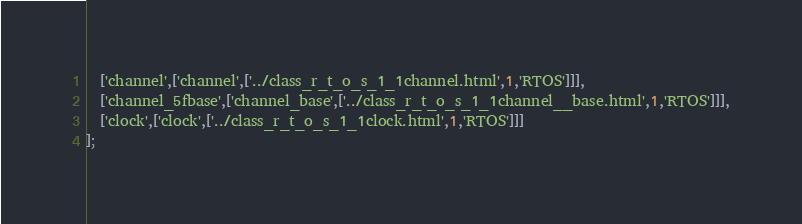<code> <loc_0><loc_0><loc_500><loc_500><_JavaScript_>  ['channel',['channel',['../class_r_t_o_s_1_1channel.html',1,'RTOS']]],
  ['channel_5fbase',['channel_base',['../class_r_t_o_s_1_1channel__base.html',1,'RTOS']]],
  ['clock',['clock',['../class_r_t_o_s_1_1clock.html',1,'RTOS']]]
];
</code> 